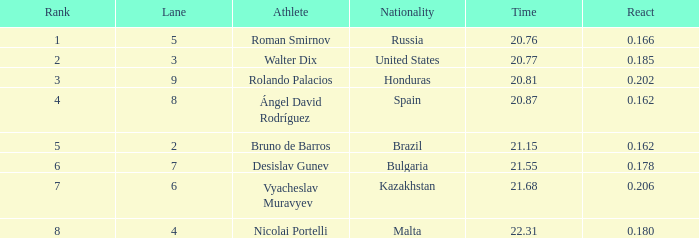What was russia's ranking before they reached the 1st place? None. 